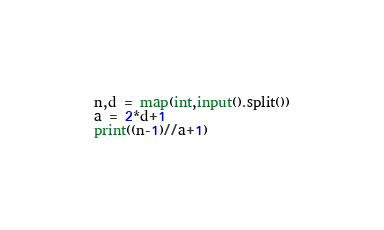Convert code to text. <code><loc_0><loc_0><loc_500><loc_500><_Python_>n,d = map(int,input().split())
a = 2*d+1
print((n-1)//a+1)</code> 